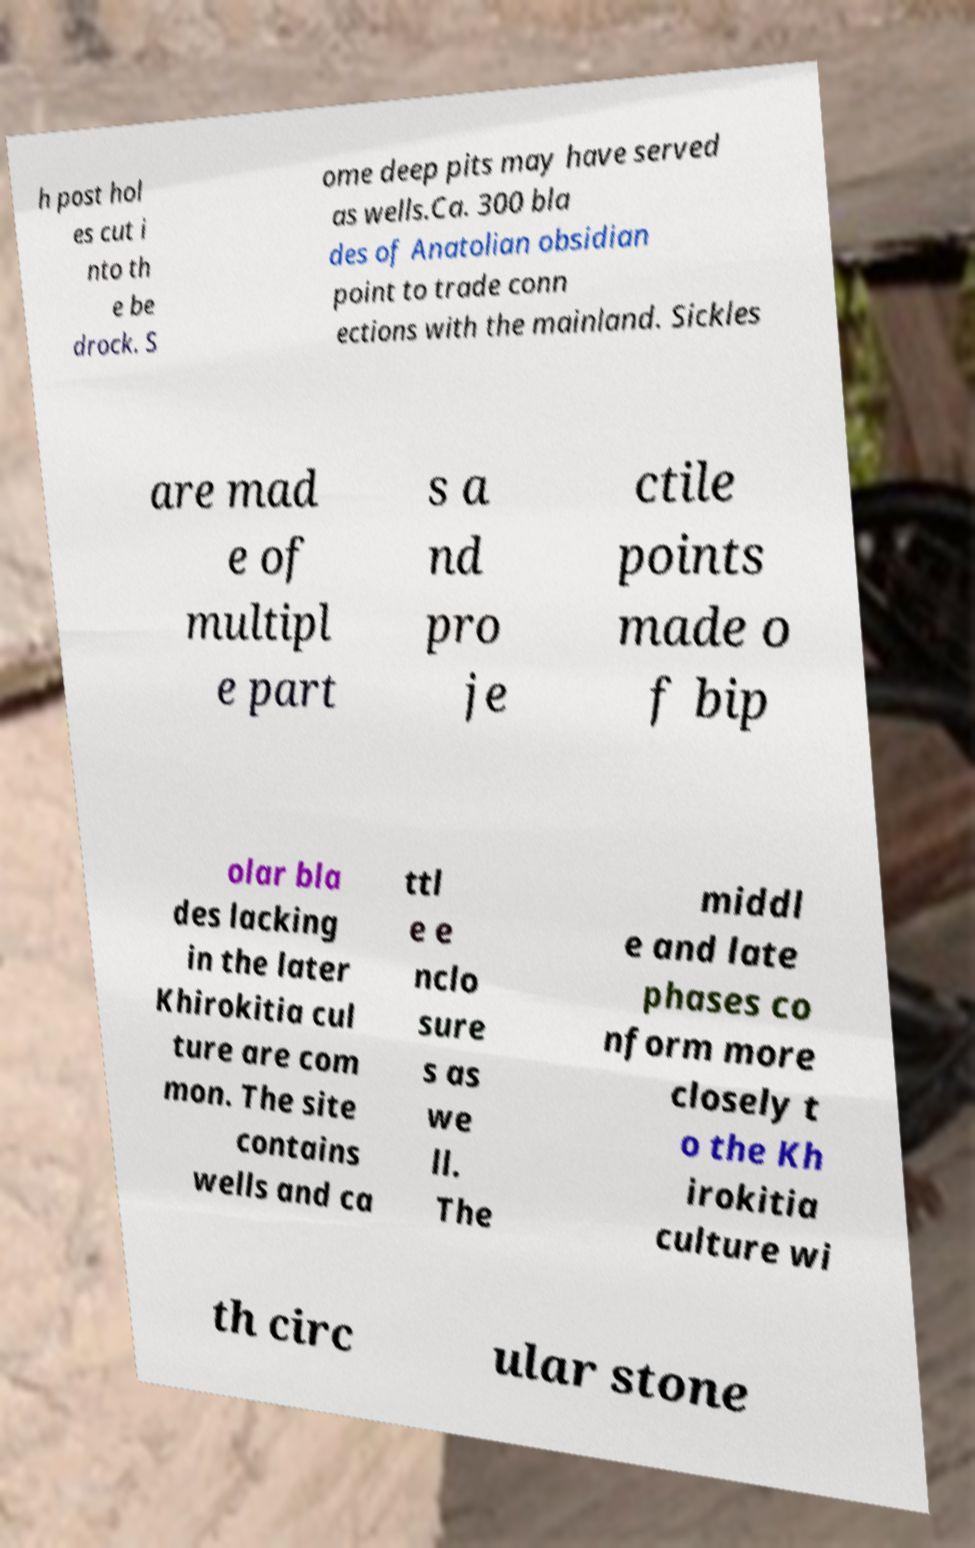Please read and relay the text visible in this image. What does it say? h post hol es cut i nto th e be drock. S ome deep pits may have served as wells.Ca. 300 bla des of Anatolian obsidian point to trade conn ections with the mainland. Sickles are mad e of multipl e part s a nd pro je ctile points made o f bip olar bla des lacking in the later Khirokitia cul ture are com mon. The site contains wells and ca ttl e e nclo sure s as we ll. The middl e and late phases co nform more closely t o the Kh irokitia culture wi th circ ular stone 